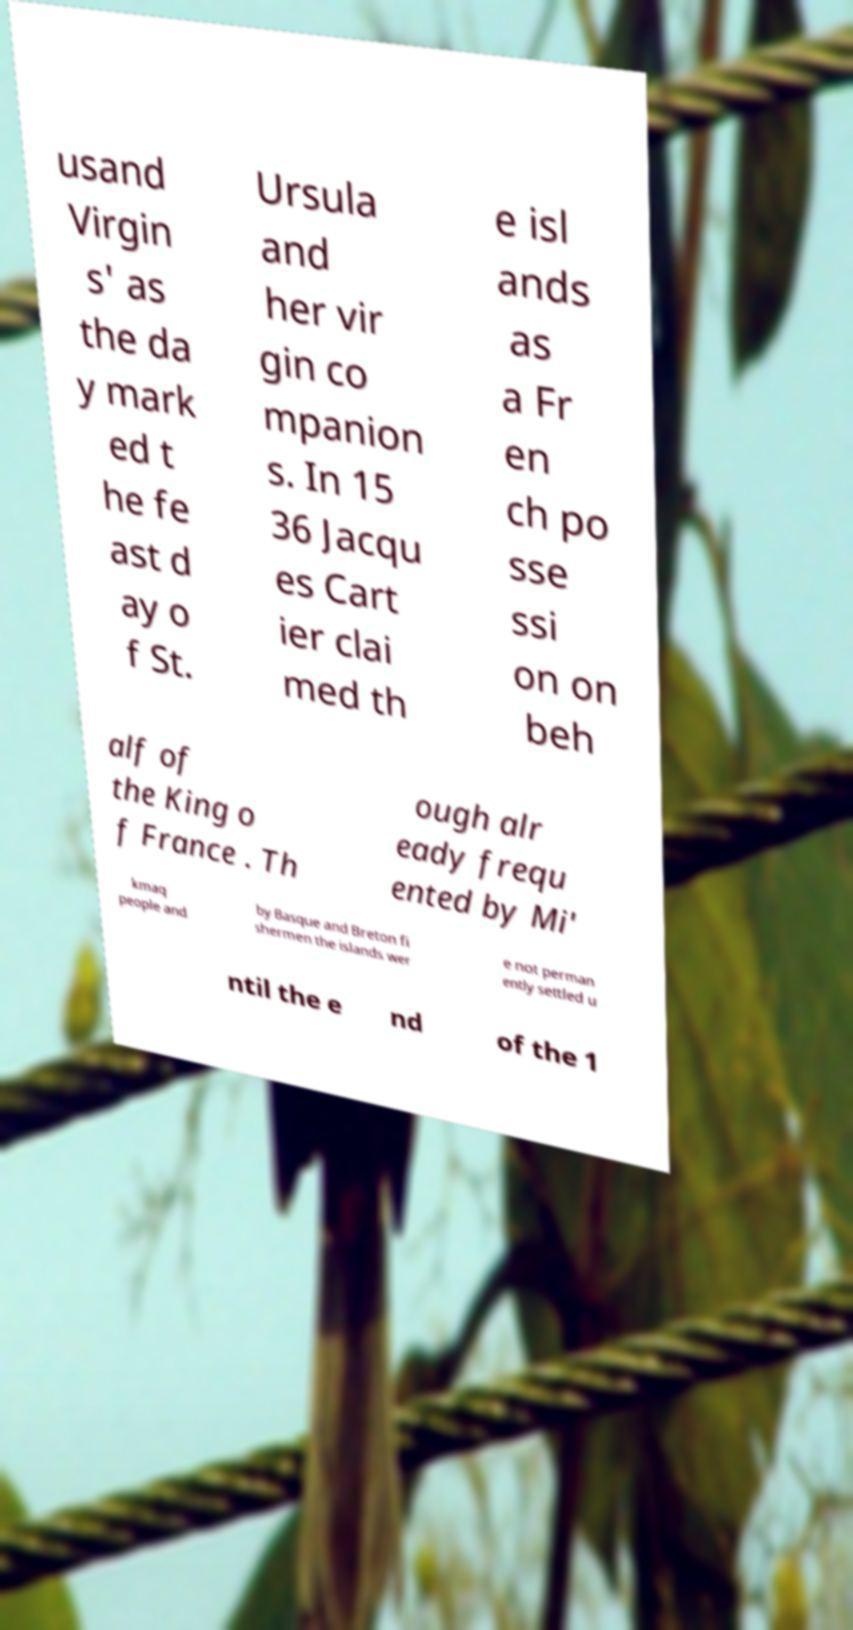Please identify and transcribe the text found in this image. usand Virgin s' as the da y mark ed t he fe ast d ay o f St. Ursula and her vir gin co mpanion s. In 15 36 Jacqu es Cart ier clai med th e isl ands as a Fr en ch po sse ssi on on beh alf of the King o f France . Th ough alr eady frequ ented by Mi' kmaq people and by Basque and Breton fi shermen the islands wer e not perman ently settled u ntil the e nd of the 1 